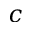Convert formula to latex. <formula><loc_0><loc_0><loc_500><loc_500>c</formula> 